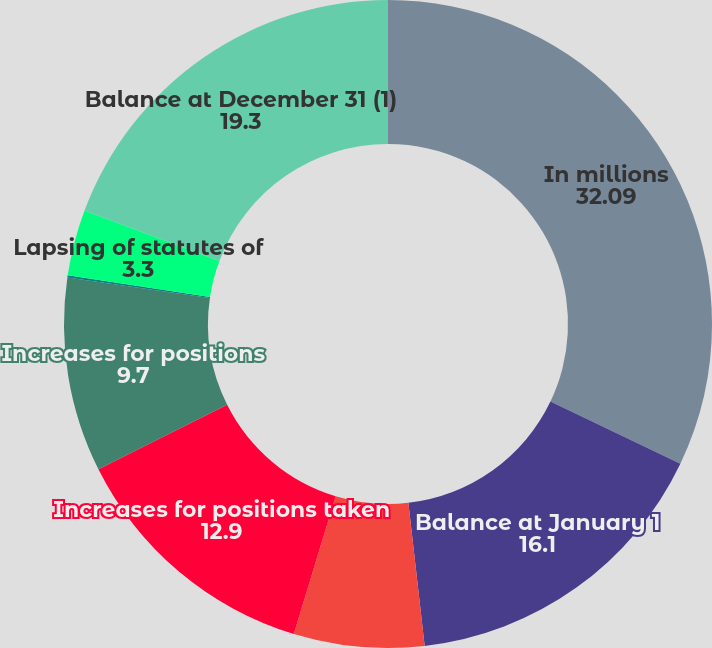<chart> <loc_0><loc_0><loc_500><loc_500><pie_chart><fcel>In millions<fcel>Balance at January 1<fcel>Decreases for positions taken<fcel>Increases for positions taken<fcel>Increases for positions<fcel>Settlements with taxing<fcel>Lapsing of statutes of<fcel>Balance at December 31 (1)<nl><fcel>32.09%<fcel>16.1%<fcel>6.5%<fcel>12.9%<fcel>9.7%<fcel>0.1%<fcel>3.3%<fcel>19.3%<nl></chart> 